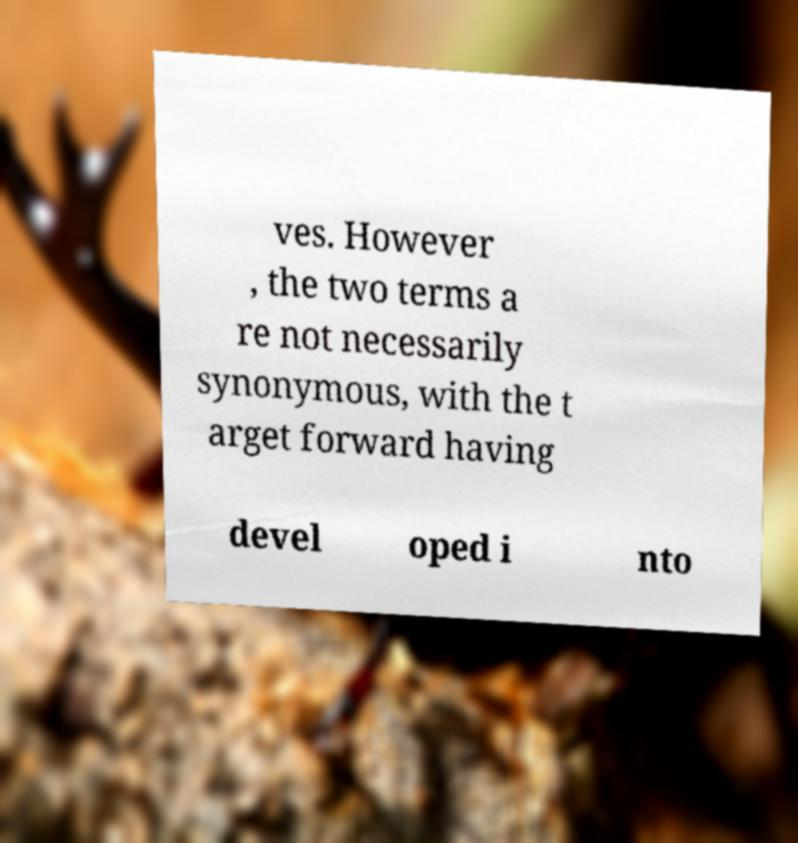Please read and relay the text visible in this image. What does it say? ves. However , the two terms a re not necessarily synonymous, with the t arget forward having devel oped i nto 